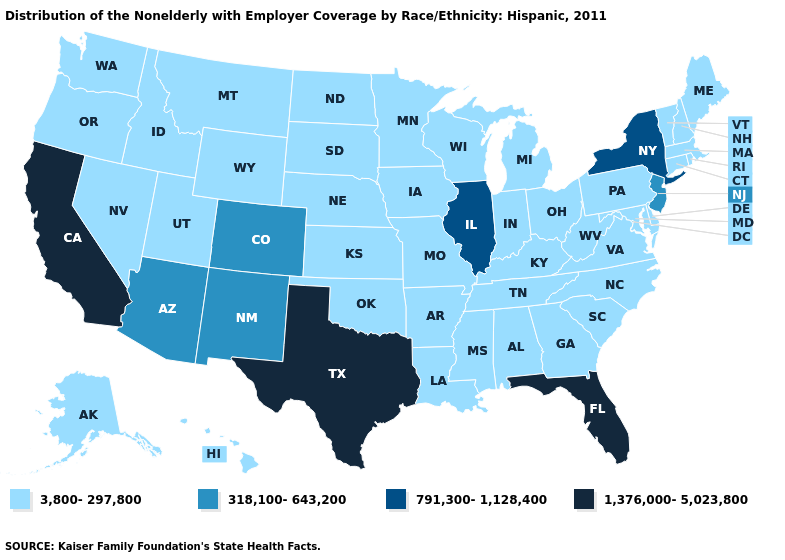What is the value of Alabama?
Write a very short answer. 3,800-297,800. Does Louisiana have the lowest value in the USA?
Concise answer only. Yes. Name the states that have a value in the range 791,300-1,128,400?
Be succinct. Illinois, New York. Does Texas have the highest value in the USA?
Short answer required. Yes. What is the lowest value in states that border Texas?
Answer briefly. 3,800-297,800. Name the states that have a value in the range 1,376,000-5,023,800?
Concise answer only. California, Florida, Texas. Name the states that have a value in the range 318,100-643,200?
Keep it brief. Arizona, Colorado, New Jersey, New Mexico. Does Kansas have a lower value than Louisiana?
Answer briefly. No. Name the states that have a value in the range 3,800-297,800?
Concise answer only. Alabama, Alaska, Arkansas, Connecticut, Delaware, Georgia, Hawaii, Idaho, Indiana, Iowa, Kansas, Kentucky, Louisiana, Maine, Maryland, Massachusetts, Michigan, Minnesota, Mississippi, Missouri, Montana, Nebraska, Nevada, New Hampshire, North Carolina, North Dakota, Ohio, Oklahoma, Oregon, Pennsylvania, Rhode Island, South Carolina, South Dakota, Tennessee, Utah, Vermont, Virginia, Washington, West Virginia, Wisconsin, Wyoming. How many symbols are there in the legend?
Short answer required. 4. How many symbols are there in the legend?
Give a very brief answer. 4. What is the value of Maine?
Quick response, please. 3,800-297,800. Name the states that have a value in the range 791,300-1,128,400?
Write a very short answer. Illinois, New York. Name the states that have a value in the range 791,300-1,128,400?
Keep it brief. Illinois, New York. What is the value of Texas?
Keep it brief. 1,376,000-5,023,800. 